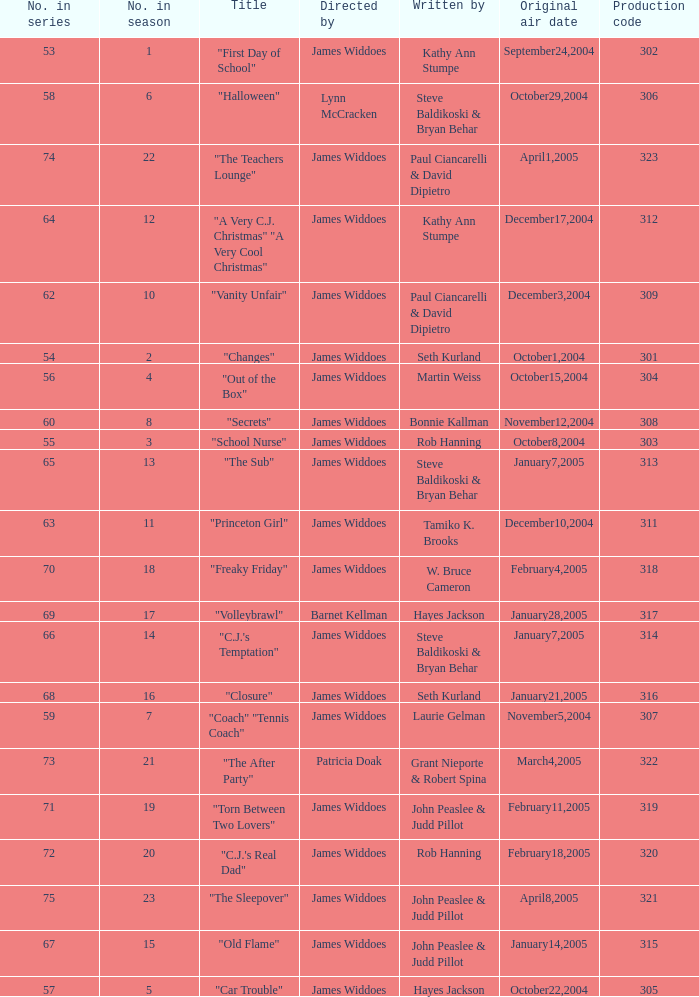How many production codes are there for "the sub"? 1.0. 